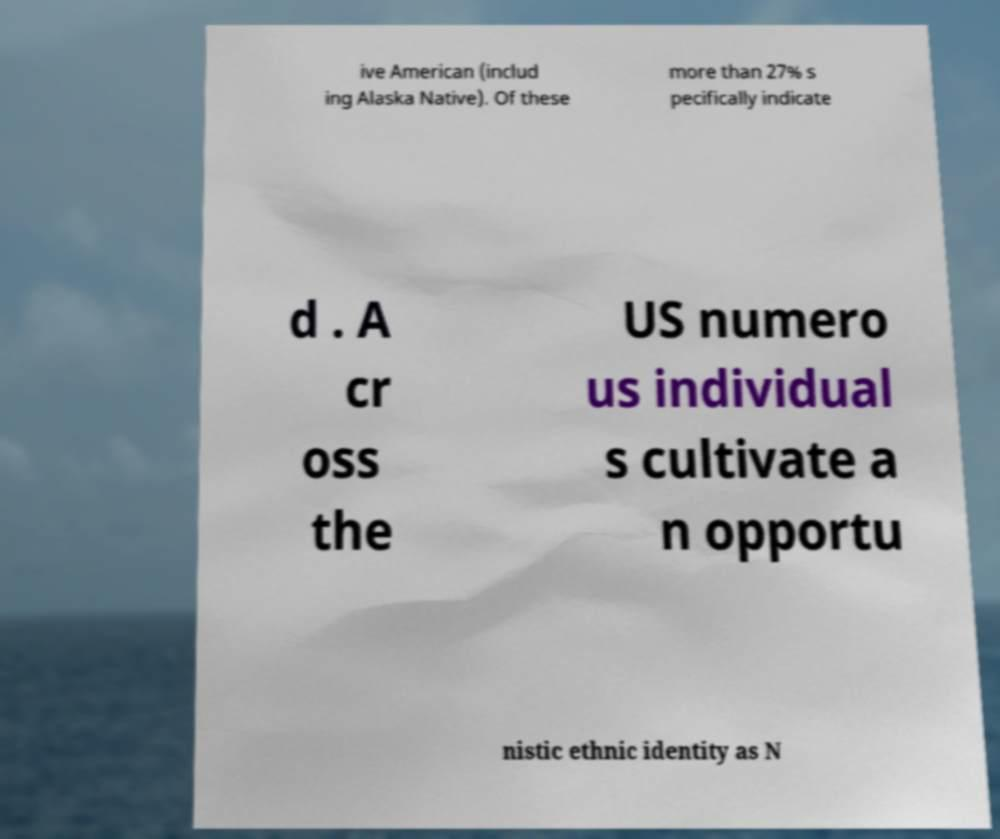Could you extract and type out the text from this image? ive American (includ ing Alaska Native). Of these more than 27% s pecifically indicate d . A cr oss the US numero us individual s cultivate a n opportu nistic ethnic identity as N 